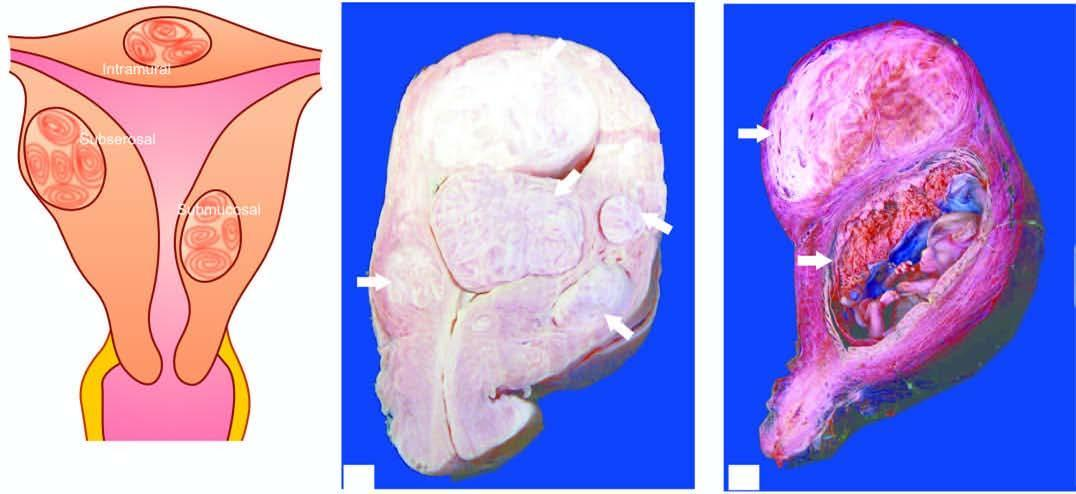does sectioned surface of the uterus show multiple circumscribed, firm nodular masses of variable sizes-submucosal in location having characteristic whorling?
Answer the question using a single word or phrase. Yes 